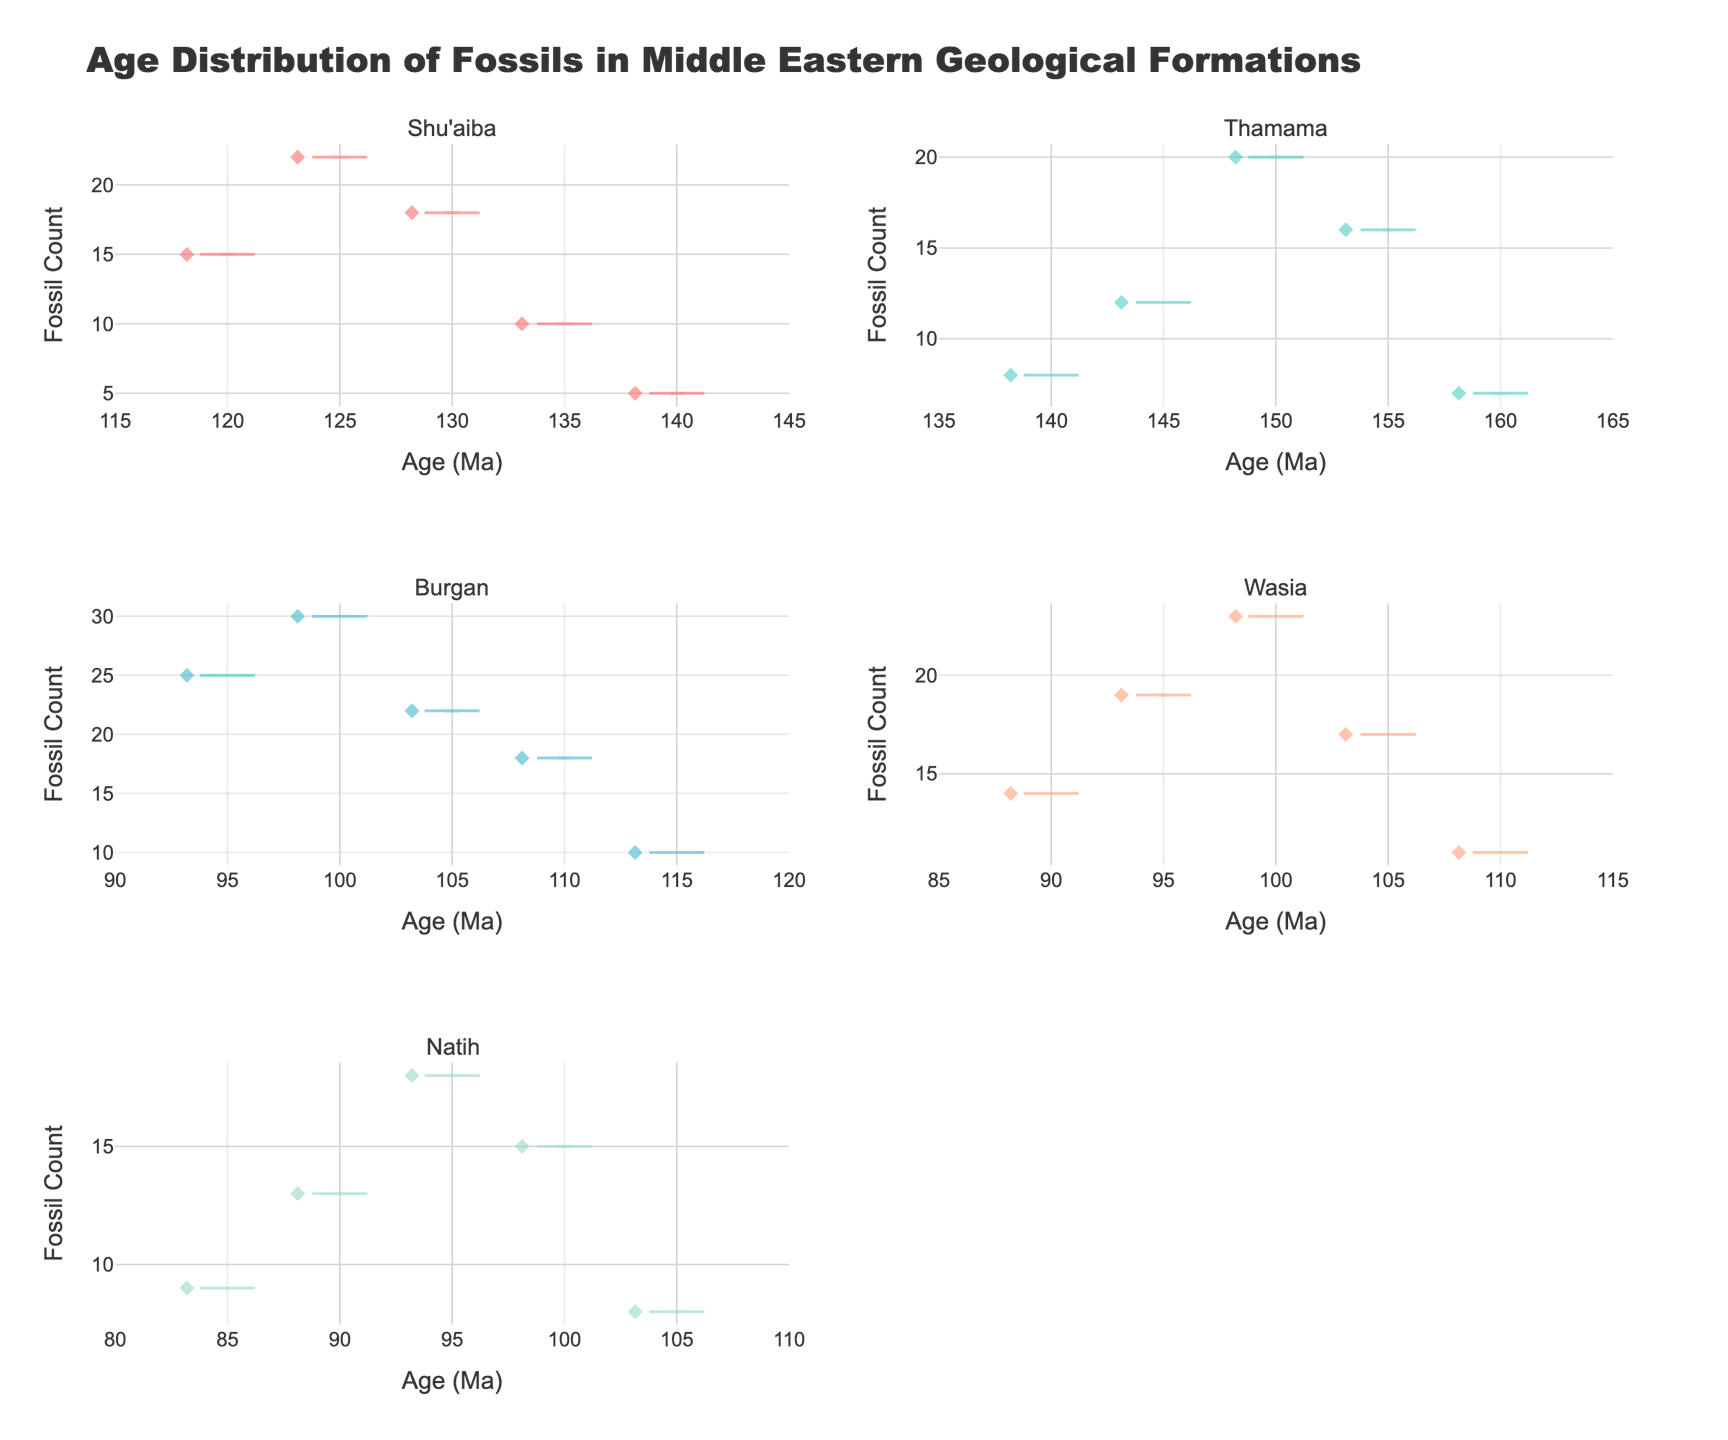What is the title of the figure? The title is generally found at the top of the figure. In this case, the title is "Age Distribution of Fossils in Middle Eastern Geological Formations."
Answer: Age Distribution of Fossils in Middle Eastern Geological Formations Which formation has the widest range of fossil ages? To determine the widest range, examine the spread of the ages on the x-axis for each subplot. The formation with the most extended x-axis range is Thamama.
Answer: Thamama Which formation has the highest maximum fossil count? Look at the highest point of the y-axis in all plots; the formation with the highest value is Burgan, reaching a maximum fossil count of around 30.
Answer: Burgan How many formations are compared in the figure? Count the number of subplot titles or distinct formations represented in each subplot. There are six different formations noted in the data and shown on the plots.
Answer: Six Which formation shows the most even distribution of fossil ages? Observing the violin plots, an even distribution means the data is spread relatively uniformly along the x-axis. Wasia appears to have a relatively even distribution of ages from 90 Ma to 110 Ma.
Answer: Wasia What is the age range for fossils in the Natih formation? Review the x-axis limits for the Natih subplot. The fossil ages range from 85 Ma to 105 Ma.
Answer: 85 Ma to 105 Ma Among the formations Shu'aiba and Thamama, which has a higher median fossil count? The median is indicated by the white line within the box plot. Shu'aiba's median is higher than Thamama's based on the visual position of the line.
Answer: Shu'aiba Is there any overlap in the age ranges of fossils between the Wasia and Burgan formations? Observe the x-axes of the Wasia and Burgan subplots. Both formations show fossil ages that overlap in the 95 Ma to 110 Ma range.
Answer: Yes Which formation's fossil counts are indicated by the color '#4ECDC4'? Check the color-coded violin plots where each formation is assigned a specific color. The formation with the color '#4ECDC4' (a teal-like color) is Thamama.
Answer: Thamama 